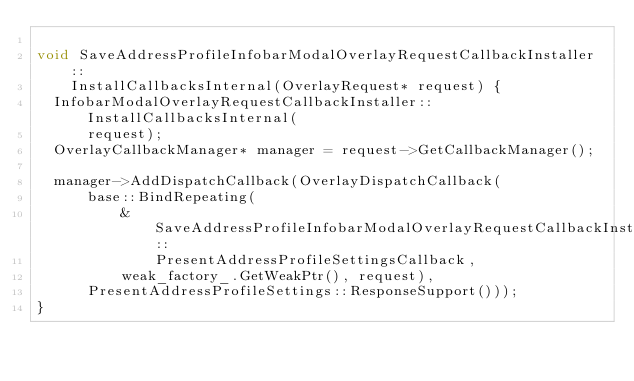Convert code to text. <code><loc_0><loc_0><loc_500><loc_500><_ObjectiveC_>
void SaveAddressProfileInfobarModalOverlayRequestCallbackInstaller::
    InstallCallbacksInternal(OverlayRequest* request) {
  InfobarModalOverlayRequestCallbackInstaller::InstallCallbacksInternal(
      request);
  OverlayCallbackManager* manager = request->GetCallbackManager();

  manager->AddDispatchCallback(OverlayDispatchCallback(
      base::BindRepeating(
          &SaveAddressProfileInfobarModalOverlayRequestCallbackInstaller::
              PresentAddressProfileSettingsCallback,
          weak_factory_.GetWeakPtr(), request),
      PresentAddressProfileSettings::ResponseSupport()));
}
</code> 